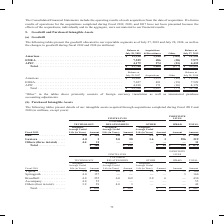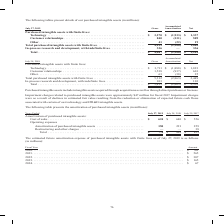From Cisco Systems's financial document, Which years does the table provide information for the amortization of purchased intangible assets? The document contains multiple relevant values: 2019, 2018, 2017. From the document: "Years Ended July 27, 2019 July 28, 2018 July 29, 2017 Amortization of purchased intangible assets: Cost of sales . $ 624 $ 640 $ 556 Operating expense..." Also, What were the cost of sales in 2019? According to the financial document, 624 (in millions). The relevant text states: "of purchased intangible assets: Cost of sales . $ 624 $ 640 $ 556 Operating expenses Amortization of purchased intangible assets . 150 221 259 Restructur..." Also, What was the total amortization of purchased intangible assets in 2018? According to the financial document, 861 (in millions). The relevant text states: "turing and other charges . — — 38 Total . $ 774 $ 861 $ 853..." Also, can you calculate: What was the change in cost of sales between 2017 and 2018? Based on the calculation: 640-556, the result is 84 (in millions). This is based on the information: "intangible assets: Cost of sales . $ 624 $ 640 $ 556 Operating expenses Amortization of purchased intangible assets . 150 221 259 Restructuring and othe chased intangible assets: Cost of sales . $ 624..." The key data points involved are: 556, 640. Also, How many years did Amortization of purchased intangible assets exceed $200 million? Counting the relevant items in the document: 2018, 2017, I find 2 instances. The key data points involved are: 2017, 2018. Also, can you calculate: What was the percentage change in total amortization of purchased intangible assets between 2018 and 2019? To answer this question, I need to perform calculations using the financial data. The calculation is: (774-861)/861, which equals -10.1 (percentage). This is based on the information: "turing and other charges . — — 38 Total . $ 774 $ 861 $ 853 estructuring and other charges . — — 38 Total . $ 774 $ 861 $ 853..." The key data points involved are: 774, 861. 